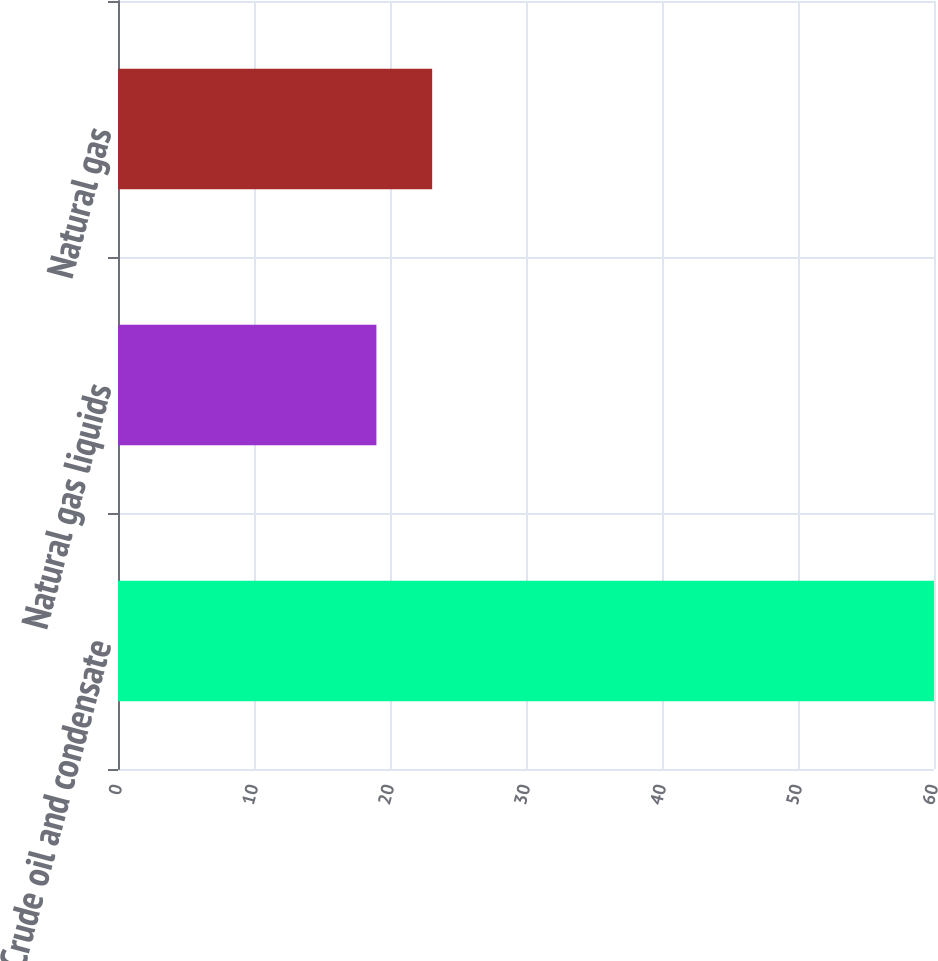<chart> <loc_0><loc_0><loc_500><loc_500><bar_chart><fcel>Crude oil and condensate<fcel>Natural gas liquids<fcel>Natural gas<nl><fcel>60<fcel>19<fcel>23.1<nl></chart> 